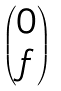<formula> <loc_0><loc_0><loc_500><loc_500>\begin{pmatrix} 0 \\ f \end{pmatrix}</formula> 